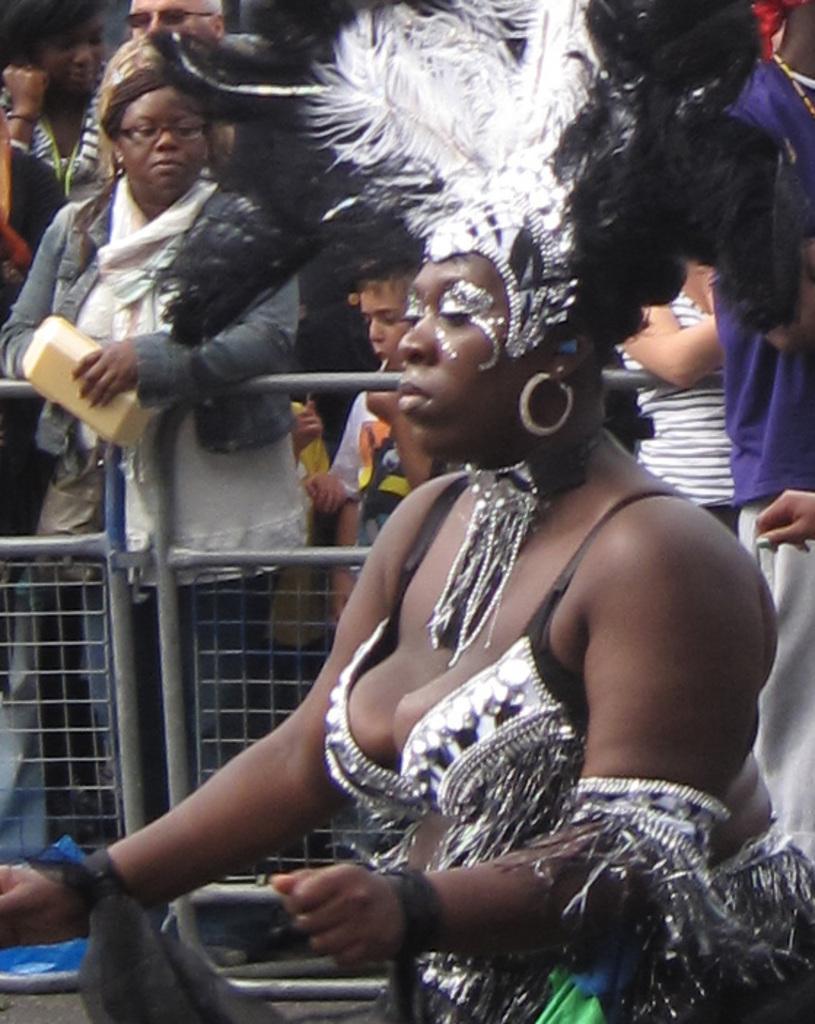Could you give a brief overview of what you see in this image? There is a woman in the foreground area of the image, there are other people and a boundary in the background. 